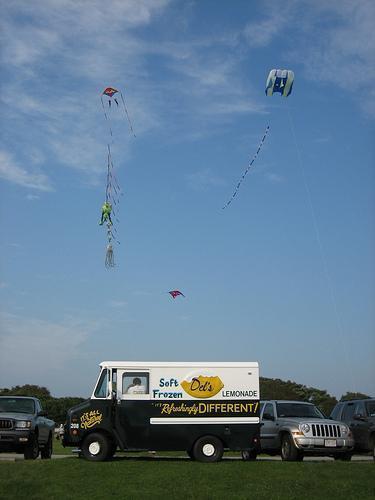How many kites are there?
Give a very brief answer. 3. How many trucks are in the photo?
Give a very brief answer. 3. How many different kinds of apples are there?
Give a very brief answer. 0. 